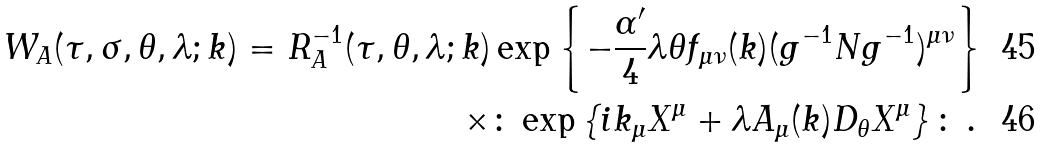<formula> <loc_0><loc_0><loc_500><loc_500>W _ { A } ( \tau , \sigma , \theta , \lambda ; k ) = R _ { A } ^ { - 1 } ( \tau , \theta , \lambda ; k ) & \exp \left \{ - \frac { \alpha ^ { \prime } } { 4 } { \lambda \theta } f _ { \mu \nu } ( k ) ( g ^ { - 1 } N g ^ { - 1 } ) ^ { \mu \nu } \right \} \\ \times & \colon \exp \left \{ i k _ { \mu } X ^ { \mu } + \lambda { A _ { \mu } ( k ) } D _ { \theta } X ^ { \mu } \right \} \colon \, .</formula> 